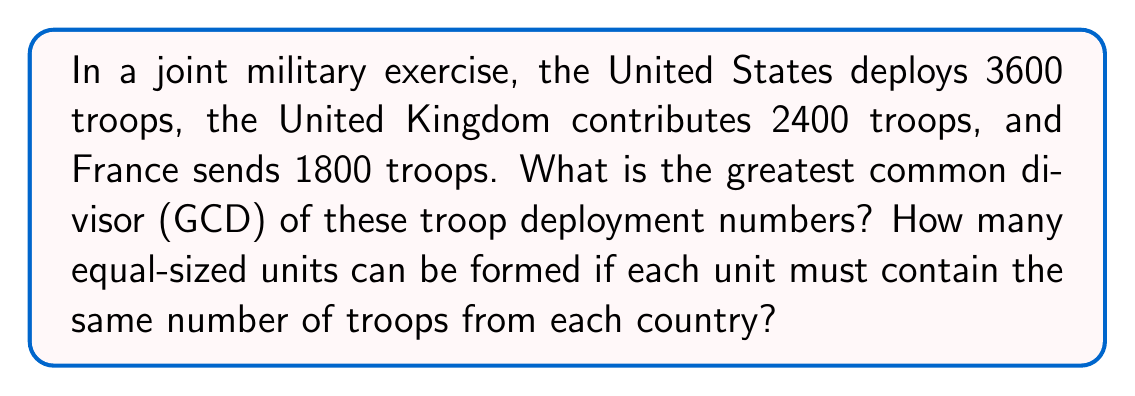Teach me how to tackle this problem. To solve this problem, we need to find the greatest common divisor (GCD) of 3600, 2400, and 1800. We can use the Euclidean algorithm repeatedly:

1) First, let's find the GCD of 3600 and 2400:
   $3600 = 1 \times 2400 + 1200$
   $2400 = 2 \times 1200 + 0$
   Therefore, $GCD(3600, 2400) = 1200$

2) Now, let's find the GCD of 1200 and 1800:
   $1800 = 1 \times 1200 + 600$
   $1200 = 2 \times 600 + 0$
   Therefore, $GCD(1200, 1800) = 600$

3) The GCD of all three numbers is thus 600.

To determine how many equal-sized units can be formed:
- US contribution per unit: $3600 \div 600 = 6$
- UK contribution per unit: $2400 \div 600 = 4$
- France contribution per unit: $1800 \div 600 = 3$

Each unit will consist of 6 US troops, 4 UK troops, and 3 French troops, totaling 13 troops per unit.

The number of units that can be formed is 600, as this is the size of the largest group that can be evenly divided among all three countries' deployments.
Answer: GCD = 600; 600 units can be formed 